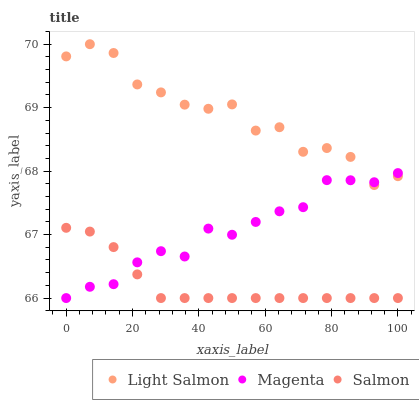Does Salmon have the minimum area under the curve?
Answer yes or no. Yes. Does Light Salmon have the maximum area under the curve?
Answer yes or no. Yes. Does Magenta have the minimum area under the curve?
Answer yes or no. No. Does Magenta have the maximum area under the curve?
Answer yes or no. No. Is Salmon the smoothest?
Answer yes or no. Yes. Is Light Salmon the roughest?
Answer yes or no. Yes. Is Magenta the smoothest?
Answer yes or no. No. Is Magenta the roughest?
Answer yes or no. No. Does Salmon have the lowest value?
Answer yes or no. Yes. Does Light Salmon have the highest value?
Answer yes or no. Yes. Does Magenta have the highest value?
Answer yes or no. No. Is Salmon less than Light Salmon?
Answer yes or no. Yes. Is Light Salmon greater than Salmon?
Answer yes or no. Yes. Does Light Salmon intersect Magenta?
Answer yes or no. Yes. Is Light Salmon less than Magenta?
Answer yes or no. No. Is Light Salmon greater than Magenta?
Answer yes or no. No. Does Salmon intersect Light Salmon?
Answer yes or no. No. 